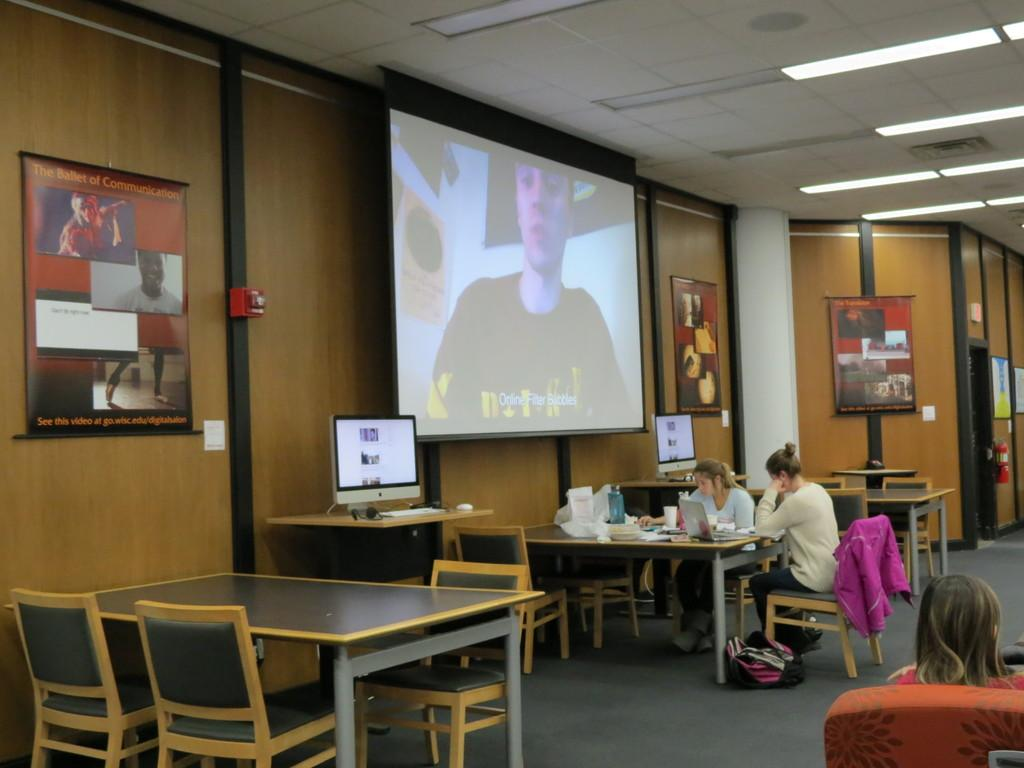What type of furniture is present in the image? There is a table and chairs in the image. What are the people in the image doing? People are sitting on the chairs. What is on the wall in the image? There is a screen on the wall. What type of electronic devices are on the table? There are monitors on the table. What type of farmer is depicted on the screen in the image? There is no farmer depicted on the screen in the image; it is a screen on the wall. What does the creator of the monitors wish for in the image? There is no information about the creator of the monitors or their wishes in the image. 